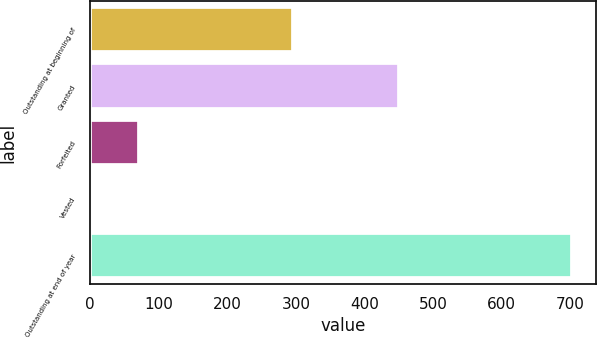Convert chart. <chart><loc_0><loc_0><loc_500><loc_500><bar_chart><fcel>Outstanding at beginning of<fcel>Granted<fcel>Forfeited<fcel>Vested<fcel>Outstanding at end of year<nl><fcel>296<fcel>451<fcel>71.1<fcel>1<fcel>702<nl></chart> 